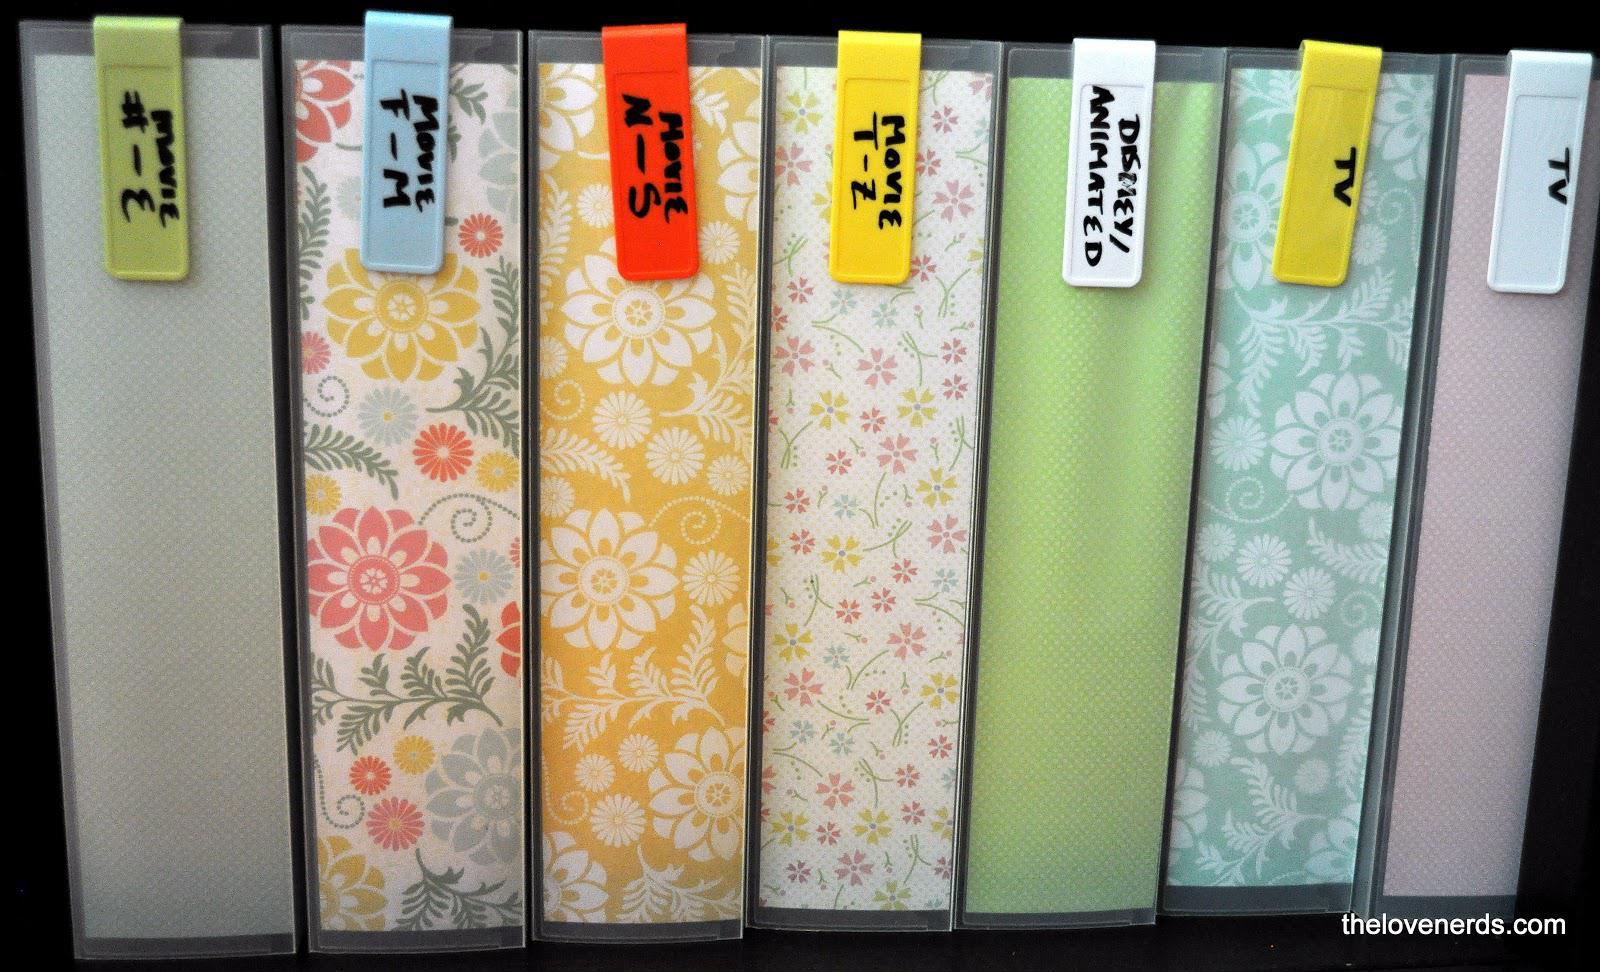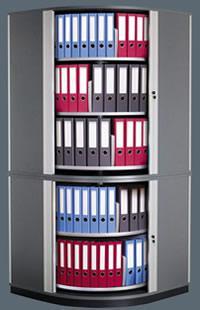The first image is the image on the left, the second image is the image on the right. For the images shown, is this caption "One image shows a wall of shelves containing vertical binders, and the other image includes at least one open binder filled with plastic-sheeted items." true? Answer yes or no. No. The first image is the image on the left, the second image is the image on the right. Assess this claim about the two images: "There are rows of colorful binders and an open binder.". Correct or not? Answer yes or no. No. 